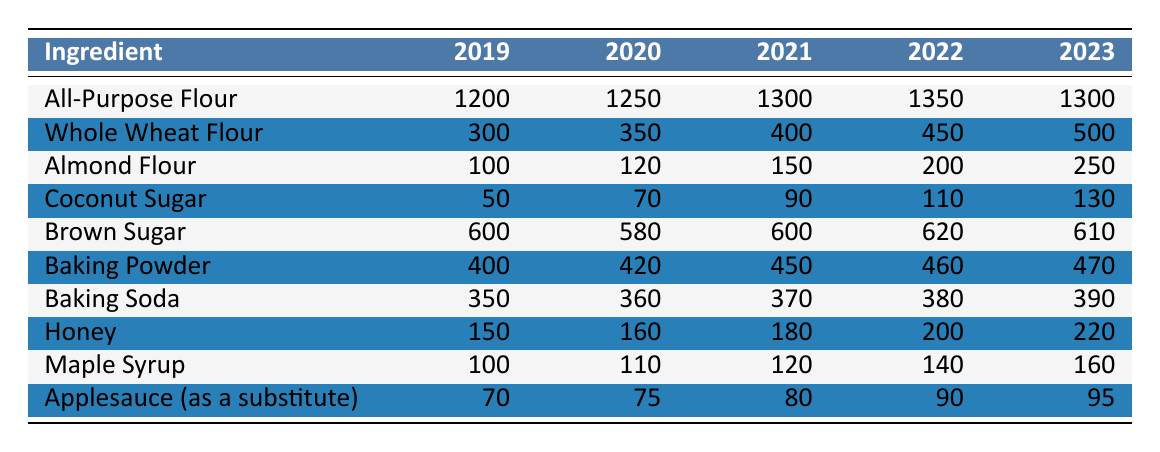What was the highest usage of Almond Flour, and in which year did it occur? The highest usage of Almond Flour occurred in 2023, with a value of 250.
Answer: 250 in 2023 What is the total usage of Whole Wheat Flour over the five years? Adding the values for Whole Wheat Flour from 2019 to 2023 gives 300 + 350 + 400 + 450 + 500 = 2000.
Answer: 2000 Did the usage of Brown Sugar increase from 2019 to 2023? Comparing the values, Brown Sugar went from 600 in 2019 to 610 in 2023, which shows an increase.
Answer: Yes What was the average usage of Honey over the five years? The sum of Honey usage is 150 + 160 + 180 + 200 + 220 = 910, and dividing by 5 gives an average of 182.
Answer: 182 In which year did Baking Powder experience the most significant increase? The largest increase for Baking Powder was from 2019 to 2020, where it rose from 400 to 420, an increase of 20 units.
Answer: 2019 to 2020 What is the percentage increase of Coconut Sugar usage from 2019 to 2023? The usage in 2019 was 50 and in 2023 it is 130. The increase is 130 - 50 = 80. The percentage increase is (80/50) * 100 = 160%.
Answer: 160% Which ingredient had the lowest total usage over the five years? The total usages are: Almond Flour (250), Coconut Sugar (130), etc. The lowest total is for Coconut Sugar at 400 (50 + 70 + 90 + 110 + 130).
Answer: Coconut Sugar What was the difference in usage between All-Purpose Flour in 2022 and Almond Flour in 2023? All-Purpose Flour usage in 2022 is 1350, and Almond Flour in 2023 is 250. The difference is 1350 - 250 = 1100.
Answer: 1100 What trend is observed in the usage of Whole Wheat Flour over the five years? Whole Wheat Flour consistently increased each year from 300 in 2019 to 500 in 2023.
Answer: Increasing Which sweetener had the highest increase in usage from 2019 to 2023? Looking at the sweeteners, Honey increased from 150 to 220, which is a total increase of 70. Maple Syrup also increased but less, so Honey has the highest increase.
Answer: Honey 